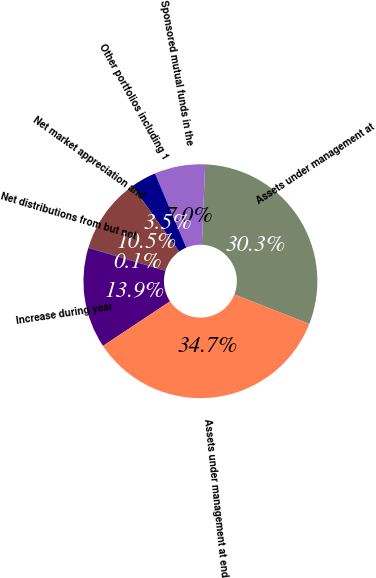Convert chart to OTSL. <chart><loc_0><loc_0><loc_500><loc_500><pie_chart><fcel>Assets under management at<fcel>Sponsored mutual funds in the<fcel>Other portfolios including 1<fcel>Net market appreciation and<fcel>Net distributions from but not<fcel>Increase during year<fcel>Assets under management at end<nl><fcel>30.3%<fcel>7.0%<fcel>3.53%<fcel>10.46%<fcel>0.06%<fcel>13.93%<fcel>34.72%<nl></chart> 